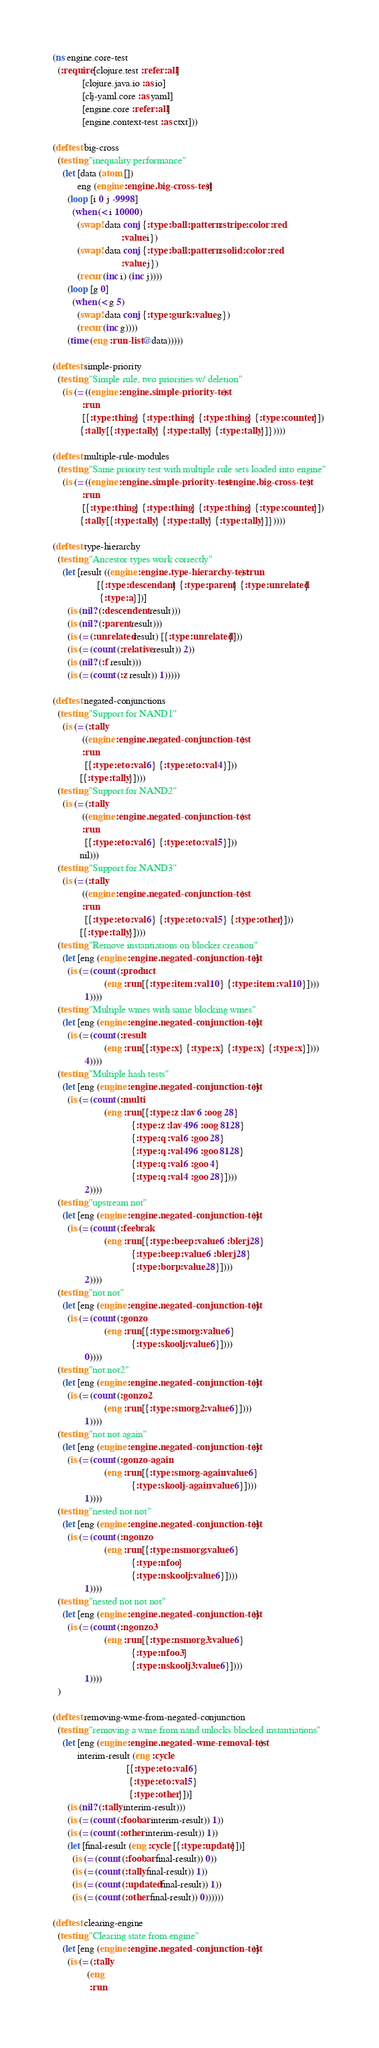<code> <loc_0><loc_0><loc_500><loc_500><_Clojure_>(ns engine.core-test
  (:require [clojure.test :refer :all]
            [clojure.java.io :as io]
            [clj-yaml.core :as yaml]
            [engine.core :refer :all]
            [engine.context-test :as ctxt]))

(deftest big-cross
  (testing "inequality performance"
    (let [data (atom [])
          eng (engine :engine.big-cross-test)]
      (loop [i 0 j -9998]
        (when (< i 10000)
          (swap! data conj {:type :ball :pattern :stripe :color :red
                            :value i})
          (swap! data conj {:type :ball :pattern :solid :color :red
                            :value j})
          (recur (inc i) (inc j))))
      (loop [g 0]
        (when (< g 5)
          (swap! data conj {:type :gurk :value g})
          (recur (inc g))))
      (time (eng :run-list @data)))))

(deftest simple-priority
  (testing "Simple rule, two priorities w/ deletion"
    (is (= ((engine :engine.simple-priority-test)
            :run
            [{:type :thing} {:type :thing} {:type :thing} {:type :counter}])
           {:tally [{:type :tally} {:type :tally} {:type :tally}]}))))

(deftest multiple-rule-modules
  (testing "Same priority test with multiple rule sets loaded into engine"
    (is (= ((engine :engine.simple-priority-test :engine.big-cross-test)
            :run
            [{:type :thing} {:type :thing} {:type :thing} {:type :counter}])
           {:tally [{:type :tally} {:type :tally} {:type :tally}]}))))

(deftest type-hierarchy
  (testing "Ancestor types work correctly"
    (let [result ((engine :engine.type-hierarchy-test) :run
                  [{:type :descendant} {:type :parent} {:type :unrelated}
                   {:type :a}])]
      (is (nil? (:descendent result)))
      (is (nil? (:parent result)))
      (is (= (:unrelated result) [{:type :unrelated}]))
      (is (= (count (:relative result)) 2))
      (is (nil? (:f result)))
      (is (= (count (:z result)) 1)))))

(deftest negated-conjunctions
  (testing "Support for NAND1"
    (is (= (:tally
            ((engine :engine.negated-conjunction-test)
            :run
             [{:type :eto :val 6} {:type :eto :val 4}]))
           [{:type :tally}])))
  (testing "Support for NAND2"
    (is (= (:tally
            ((engine :engine.negated-conjunction-test)
            :run
             [{:type :eto :val 6} {:type :eto :val 5}]))
           nil)))
  (testing "Support for NAND3"
    (is (= (:tally
            ((engine :engine.negated-conjunction-test)
            :run
             [{:type :eto :val 6} {:type :eto :val 5} {:type :other}]))
           [{:type :tally}])))
  (testing "Remove instantiations on blocker creation"
    (let [eng (engine :engine.negated-conjunction-test)]
      (is (= (count (:product
                     (eng :run [{:type :item :val 10} {:type :item :val 10}])))
             1))))
  (testing "Multiple wmes with same blocking wmes"
    (let [eng (engine :engine.negated-conjunction-test)]
      (is (= (count (:result
                     (eng :run [{:type :x} {:type :x} {:type :x} {:type :x}])))
             4))))
  (testing "Multiple hash tests"
    (let [eng (engine :engine.negated-conjunction-test)]
      (is (= (count (:multi
                     (eng :run [{:type :z :lav 6 :oog 28}
                                {:type :z :lav 496 :oog 8128}
                                {:type :q :val 6 :goo 28}
                                {:type :q :val 496 :goo 8128}
                                {:type :q :val 6 :goo 4}
                                {:type :q :val 4 :goo 28}])))
             2))))
  (testing "upstream not"
    (let [eng (engine :engine.negated-conjunction-test)]
      (is (= (count (:feebrak
                     (eng :run [{:type :beep :value 6 :blerj 28}
                                {:type :beep :value 6 :blerj 28}
                                {:type :borp :value 28}])))
             2))))
  (testing "not not"
    (let [eng (engine :engine.negated-conjunction-test)]
      (is (= (count (:gonzo
                     (eng :run [{:type :smorg :value 6}
                                {:type :skoolj :value 6}])))
             0))))
  (testing "not not2"
    (let [eng (engine :engine.negated-conjunction-test)]
      (is (= (count (:gonzo2
                     (eng :run [{:type :smorg2 :value 6}])))
             1))))
  (testing "not not again"
    (let [eng (engine :engine.negated-conjunction-test)]
      (is (= (count (:gonzo-again
                     (eng :run [{:type :smorg-again :value 6}
                                {:type :skoolj-again :value 6}])))
             1))))
  (testing "nested not not"
    (let [eng (engine :engine.negated-conjunction-test)]
      (is (= (count (:ngonzo
                     (eng :run [{:type :nsmorg :value 6}
                                {:type :nfoo}
                                {:type :nskoolj :value 6}])))
             1))))
  (testing "nested not not not"
    (let [eng (engine :engine.negated-conjunction-test)]
      (is (= (count (:ngonzo3
                     (eng :run [{:type :nsmorg3 :value 6}
                                {:type :nfoo3}
                                {:type :nskoolj3 :value 6}])))
             1))))
  )

(deftest removing-wme-from-negated-conjunction
  (testing "removing a wme from nand unlocks blocked instantiations"
    (let [eng (engine :engine.negated-wme-removal-test)
          interim-result (eng :cycle
                              [{:type :eto :val 6}
                               {:type :eto :val 5}
                               {:type :other}])]
      (is (nil? (:tally interim-result)))
      (is (= (count (:foobar interim-result)) 1))
      (is (= (count (:other interim-result)) 1))
      (let [final-result (eng :cycle [{:type :update}])]
        (is (= (count (:foobar final-result)) 0))
        (is (= (count (:tally final-result)) 1))
        (is (= (count (:updated final-result)) 1))
        (is (= (count (:other final-result)) 0))))))

(deftest clearing-engine
  (testing "Clearing state from engine"
    (let [eng (engine :engine.negated-conjunction-test)]
      (is (= (:tally
              (eng
               :run</code> 